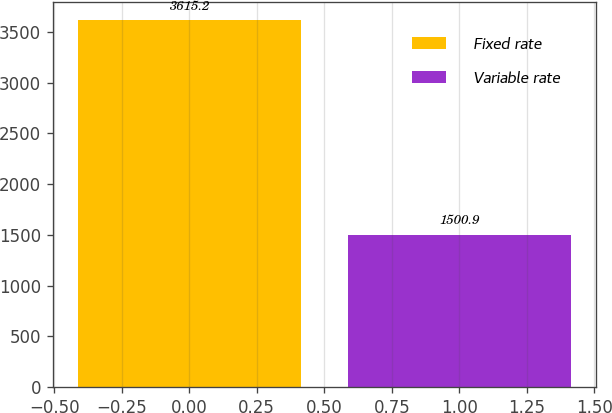Convert chart. <chart><loc_0><loc_0><loc_500><loc_500><bar_chart><fcel>Fixed rate<fcel>Variable rate<nl><fcel>3615.2<fcel>1500.9<nl></chart> 